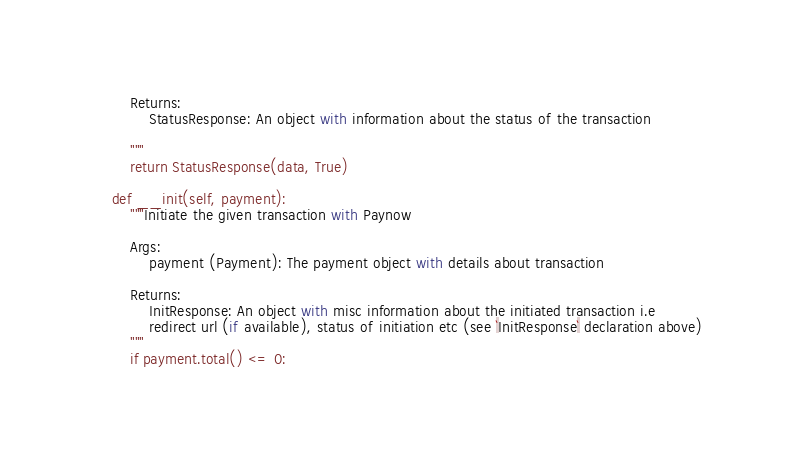Convert code to text. <code><loc_0><loc_0><loc_500><loc_500><_Python_>        Returns:
            StatusResponse: An object with information about the status of the transaction

        """
        return StatusResponse(data, True)

    def __init(self, payment):
        """Initiate the given transaction with Paynow

        Args:
            payment (Payment): The payment object with details about transaction

        Returns:
            InitResponse: An object with misc information about the initiated transaction i.e
            redirect url (if available), status of initiation etc (see `InitResponse` declaration above)
        """
        if payment.total() <= 0:</code> 